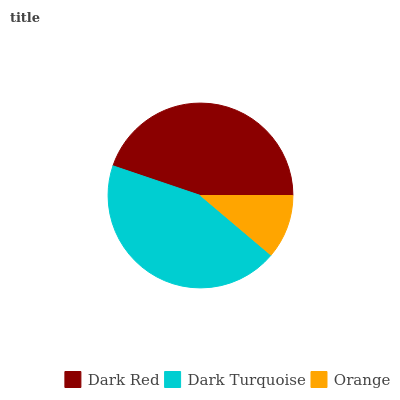Is Orange the minimum?
Answer yes or no. Yes. Is Dark Red the maximum?
Answer yes or no. Yes. Is Dark Turquoise the minimum?
Answer yes or no. No. Is Dark Turquoise the maximum?
Answer yes or no. No. Is Dark Red greater than Dark Turquoise?
Answer yes or no. Yes. Is Dark Turquoise less than Dark Red?
Answer yes or no. Yes. Is Dark Turquoise greater than Dark Red?
Answer yes or no. No. Is Dark Red less than Dark Turquoise?
Answer yes or no. No. Is Dark Turquoise the high median?
Answer yes or no. Yes. Is Dark Turquoise the low median?
Answer yes or no. Yes. Is Orange the high median?
Answer yes or no. No. Is Orange the low median?
Answer yes or no. No. 